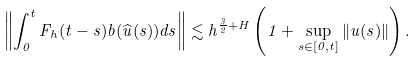Convert formula to latex. <formula><loc_0><loc_0><loc_500><loc_500>\left \| \int _ { 0 } ^ { t } F _ { h } ( t - s ) b ( \widehat { u } ( s ) ) d s \right \| \lesssim h ^ { \frac { 3 } { 2 } + H } \left ( 1 + \sup _ { s \in [ 0 , t ] } \| u ( s ) \| \right ) .</formula> 